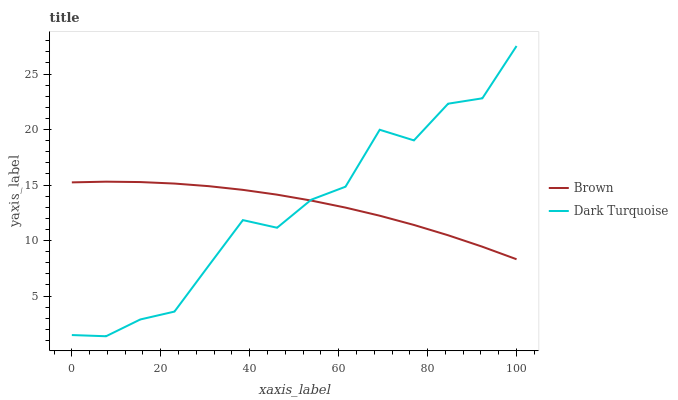Does Dark Turquoise have the minimum area under the curve?
Answer yes or no. Yes. Does Brown have the maximum area under the curve?
Answer yes or no. Yes. Does Dark Turquoise have the maximum area under the curve?
Answer yes or no. No. Is Brown the smoothest?
Answer yes or no. Yes. Is Dark Turquoise the roughest?
Answer yes or no. Yes. Is Dark Turquoise the smoothest?
Answer yes or no. No. Does Dark Turquoise have the lowest value?
Answer yes or no. Yes. Does Dark Turquoise have the highest value?
Answer yes or no. Yes. Does Brown intersect Dark Turquoise?
Answer yes or no. Yes. Is Brown less than Dark Turquoise?
Answer yes or no. No. Is Brown greater than Dark Turquoise?
Answer yes or no. No. 